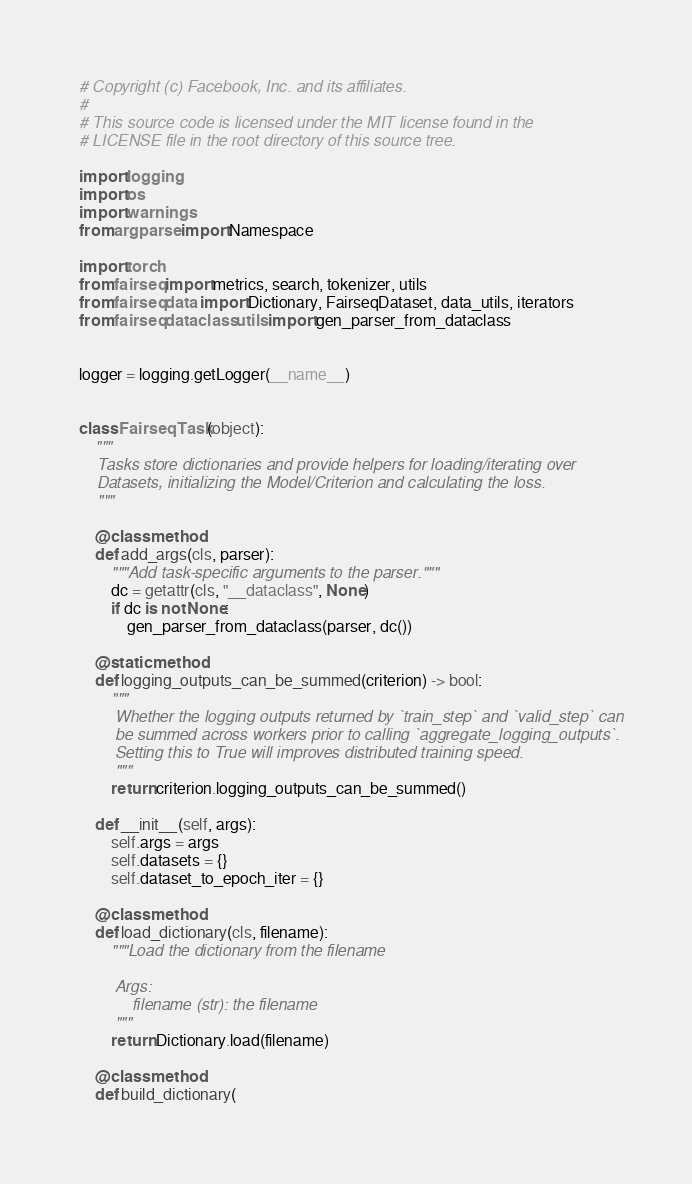Convert code to text. <code><loc_0><loc_0><loc_500><loc_500><_Python_># Copyright (c) Facebook, Inc. and its affiliates.
#
# This source code is licensed under the MIT license found in the
# LICENSE file in the root directory of this source tree.

import logging
import os
import warnings
from argparse import Namespace

import torch
from fairseq import metrics, search, tokenizer, utils
from fairseq.data import Dictionary, FairseqDataset, data_utils, iterators
from fairseq.dataclass.utils import gen_parser_from_dataclass


logger = logging.getLogger(__name__)


class FairseqTask(object):
    """
    Tasks store dictionaries and provide helpers for loading/iterating over
    Datasets, initializing the Model/Criterion and calculating the loss.
    """

    @classmethod
    def add_args(cls, parser):
        """Add task-specific arguments to the parser."""
        dc = getattr(cls, "__dataclass", None)
        if dc is not None:
            gen_parser_from_dataclass(parser, dc())

    @staticmethod
    def logging_outputs_can_be_summed(criterion) -> bool:
        """
        Whether the logging outputs returned by `train_step` and `valid_step` can
        be summed across workers prior to calling `aggregate_logging_outputs`.
        Setting this to True will improves distributed training speed.
        """
        return criterion.logging_outputs_can_be_summed()

    def __init__(self, args):
        self.args = args
        self.datasets = {}
        self.dataset_to_epoch_iter = {}

    @classmethod
    def load_dictionary(cls, filename):
        """Load the dictionary from the filename

        Args:
            filename (str): the filename
        """
        return Dictionary.load(filename)

    @classmethod
    def build_dictionary(</code> 